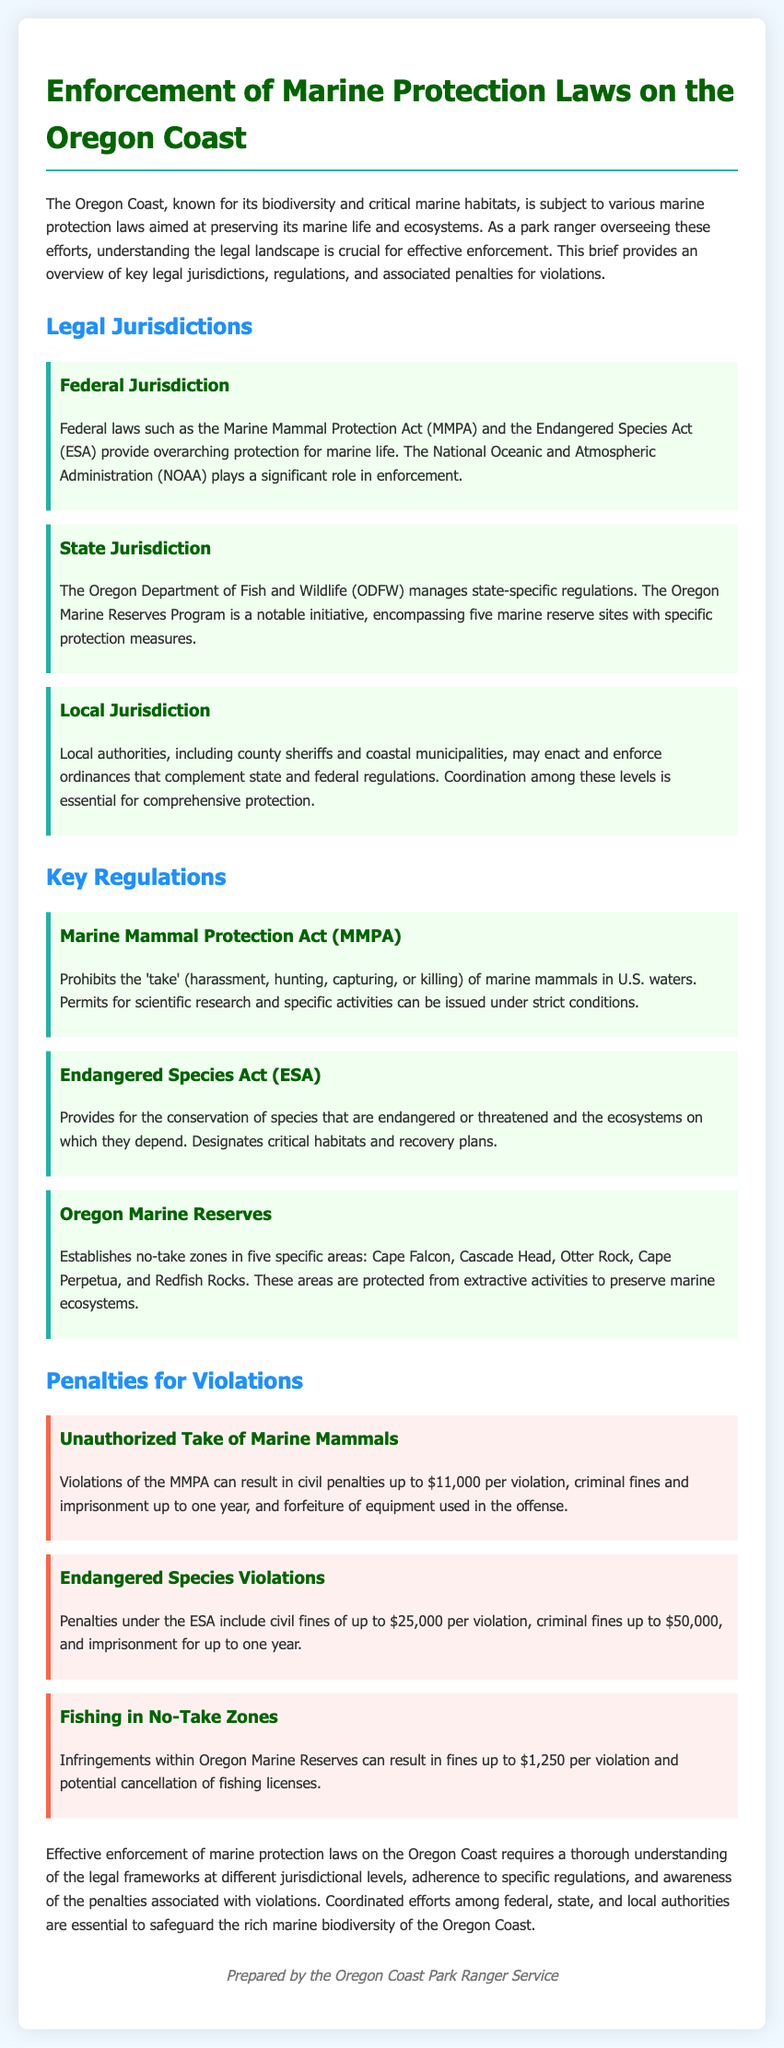What federal laws protect marine life in the Oregon Coast? The document outlines that the Marine Mammal Protection Act (MMPA) and the Endangered Species Act (ESA) provide overarching protection for marine life in U.S. waters.
Answer: MMPA and ESA Which department manages state-specific regulations? The document states that the Oregon Department of Fish and Wildlife (ODFW) is responsible for managing state-specific regulations.
Answer: Oregon Department of Fish and Wildlife (ODFW) What are the penalties for unauthorized take of marine mammals under the MMPA? According to the document, violations can result in civil penalties up to $11,000 per violation, criminal fines, and imprisonment up to one year.
Answer: Up to $11,000 How many marine reserve sites are mentioned? The document specifies that there are five marine reserve sites within the Oregon Marine Reserves Program.
Answer: Five What is the maximum civil fine under the Endangered Species Act? The document states that civil fines for violations of the Endangered Species Act can be up to $25,000 per violation.
Answer: $25,000 Which areas are established as no-take zones? The document lists Cape Falcon, Cascade Head, Otter Rock, Cape Perpetua, and Redfish Rocks as the areas established as no-take zones.
Answer: Cape Falcon, Cascade Head, Otter Rock, Cape Perpetua, Redfish Rocks What is the penalty for fishing in no-take zones? The document indicates that infringements within Oregon Marine Reserves can result in fines up to $1,250 per violation.
Answer: Up to $1,250 What role does NOAA play in the enforcement of marine protection laws? The document mentions that the National Oceanic and Atmospheric Administration (NOAA) plays a significant role in the enforcement of federal marine protection laws.
Answer: Enforcement of federal laws What is the purpose of the Oregon Marine Reserves Program? The document states that the program establishes no-take zones to preserve marine ecosystems.
Answer: Preserve marine ecosystems 